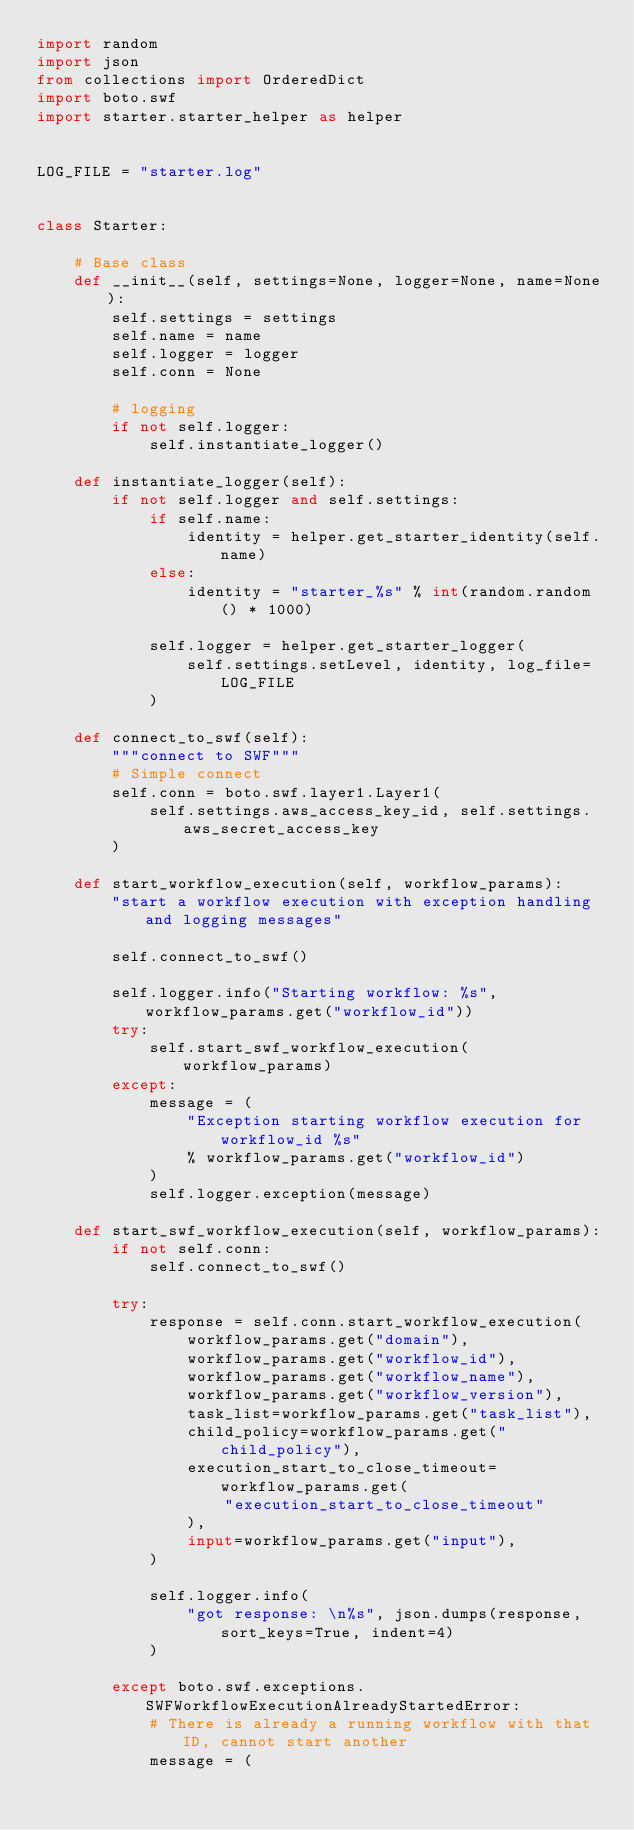<code> <loc_0><loc_0><loc_500><loc_500><_Python_>import random
import json
from collections import OrderedDict
import boto.swf
import starter.starter_helper as helper


LOG_FILE = "starter.log"


class Starter:

    # Base class
    def __init__(self, settings=None, logger=None, name=None):
        self.settings = settings
        self.name = name
        self.logger = logger
        self.conn = None

        # logging
        if not self.logger:
            self.instantiate_logger()

    def instantiate_logger(self):
        if not self.logger and self.settings:
            if self.name:
                identity = helper.get_starter_identity(self.name)
            else:
                identity = "starter_%s" % int(random.random() * 1000)

            self.logger = helper.get_starter_logger(
                self.settings.setLevel, identity, log_file=LOG_FILE
            )

    def connect_to_swf(self):
        """connect to SWF"""
        # Simple connect
        self.conn = boto.swf.layer1.Layer1(
            self.settings.aws_access_key_id, self.settings.aws_secret_access_key
        )

    def start_workflow_execution(self, workflow_params):
        "start a workflow execution with exception handling and logging messages"

        self.connect_to_swf()

        self.logger.info("Starting workflow: %s", workflow_params.get("workflow_id"))
        try:
            self.start_swf_workflow_execution(workflow_params)
        except:
            message = (
                "Exception starting workflow execution for workflow_id %s"
                % workflow_params.get("workflow_id")
            )
            self.logger.exception(message)

    def start_swf_workflow_execution(self, workflow_params):
        if not self.conn:
            self.connect_to_swf()

        try:
            response = self.conn.start_workflow_execution(
                workflow_params.get("domain"),
                workflow_params.get("workflow_id"),
                workflow_params.get("workflow_name"),
                workflow_params.get("workflow_version"),
                task_list=workflow_params.get("task_list"),
                child_policy=workflow_params.get("child_policy"),
                execution_start_to_close_timeout=workflow_params.get(
                    "execution_start_to_close_timeout"
                ),
                input=workflow_params.get("input"),
            )

            self.logger.info(
                "got response: \n%s", json.dumps(response, sort_keys=True, indent=4)
            )

        except boto.swf.exceptions.SWFWorkflowExecutionAlreadyStartedError:
            # There is already a running workflow with that ID, cannot start another
            message = (</code> 